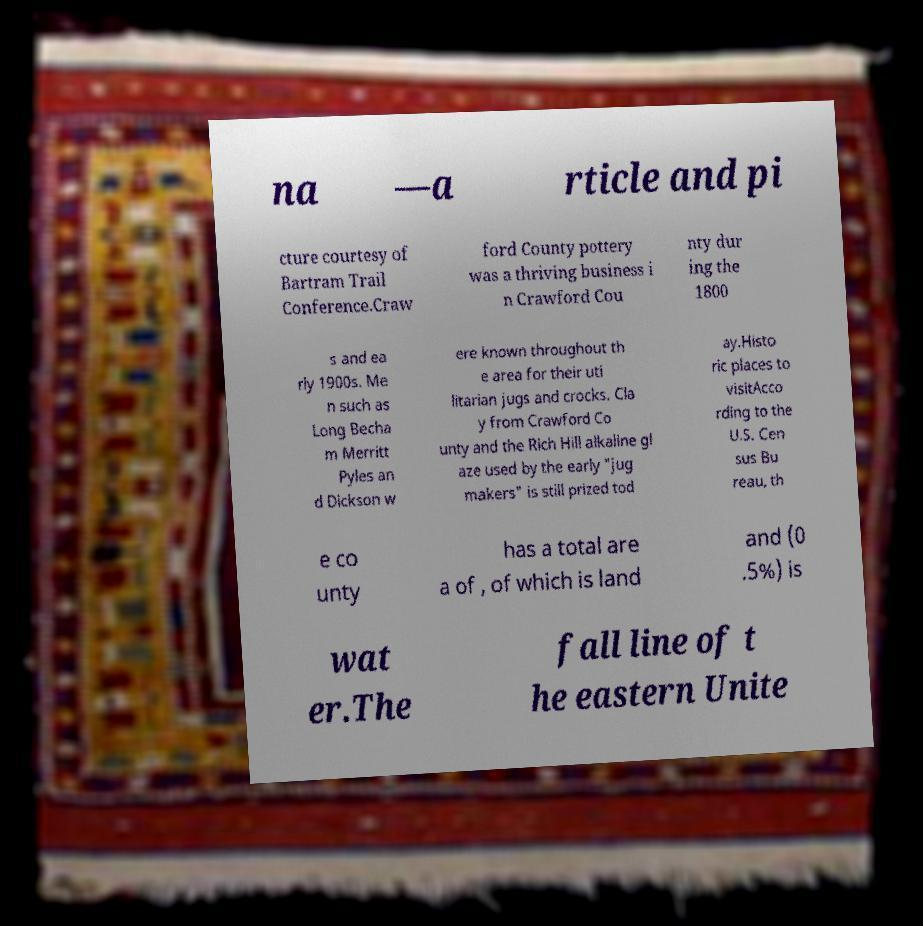Can you accurately transcribe the text from the provided image for me? na —a rticle and pi cture courtesy of Bartram Trail Conference.Craw ford County pottery was a thriving business i n Crawford Cou nty dur ing the 1800 s and ea rly 1900s. Me n such as Long Becha m Merritt Pyles an d Dickson w ere known throughout th e area for their uti litarian jugs and crocks. Cla y from Crawford Co unty and the Rich Hill alkaline gl aze used by the early "jug makers" is still prized tod ay.Histo ric places to visitAcco rding to the U.S. Cen sus Bu reau, th e co unty has a total are a of , of which is land and (0 .5%) is wat er.The fall line of t he eastern Unite 